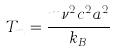<formula> <loc_0><loc_0><loc_500><loc_500>T _ { m } = \frac { m \nu ^ { 2 } c ^ { 2 } a ^ { 2 } } { k _ { B } }</formula> 